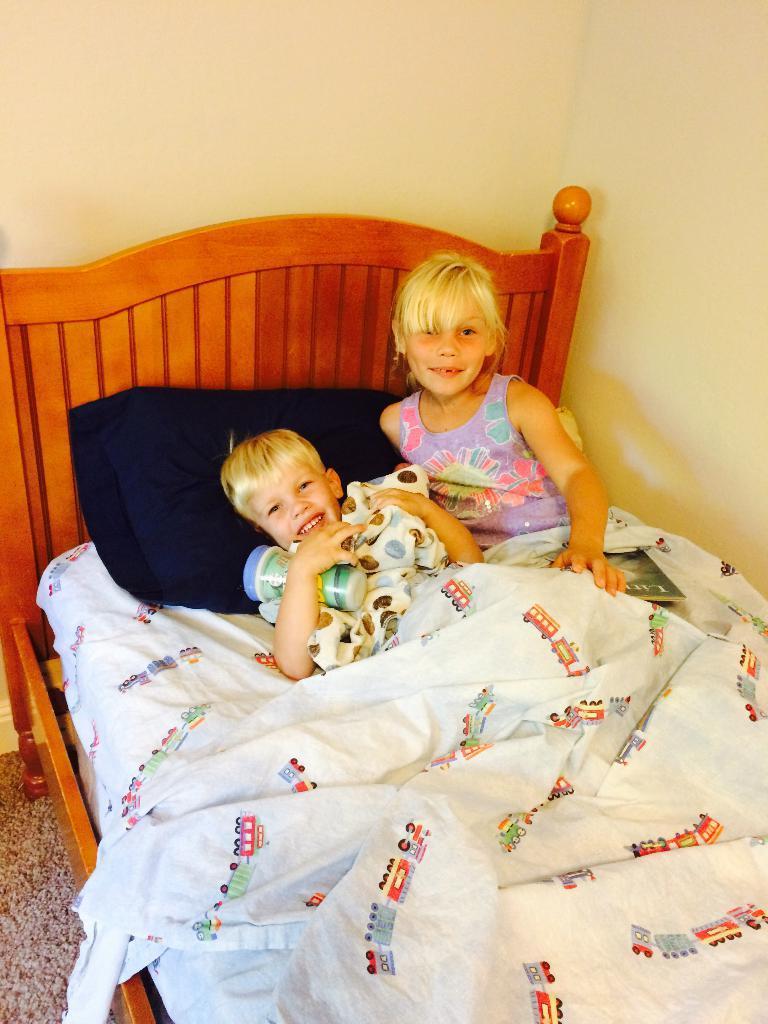Please provide a concise description of this image. In this image i can see two children lying on the bed holding a bottle covering with a blanket,the children is holding a book. At the background i can see a wall. 